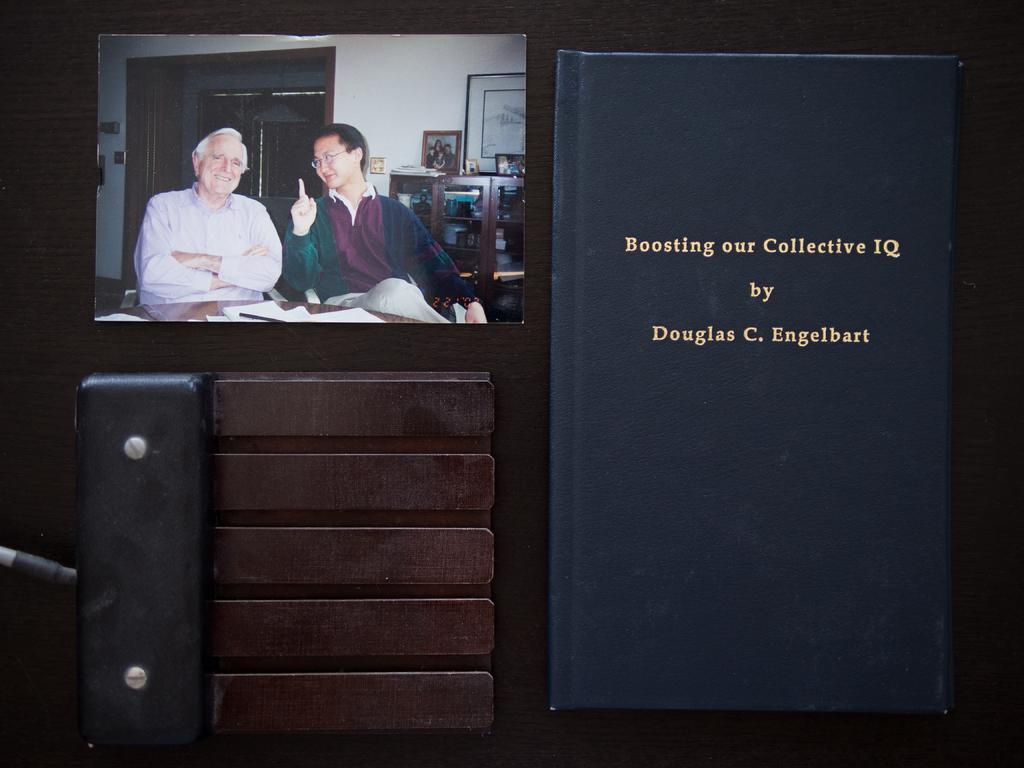What is one item visible in the image? There is a book in the image. What else can be seen in the image besides the book? There is a photo in the image. Can you describe the photo? The photo contains people and pictures. What is the object in the image? There is an object in the image, but its description is not provided in the facts. What is the setting of the photo? The photo contains a cupboard with things in it. What type of fuel is being used by the people in the photo? There is no information about fuel usage in the image or the photo. The image only shows a book, a photo, and an object, with the photo containing people and pictures in a setting with a cupboard. 